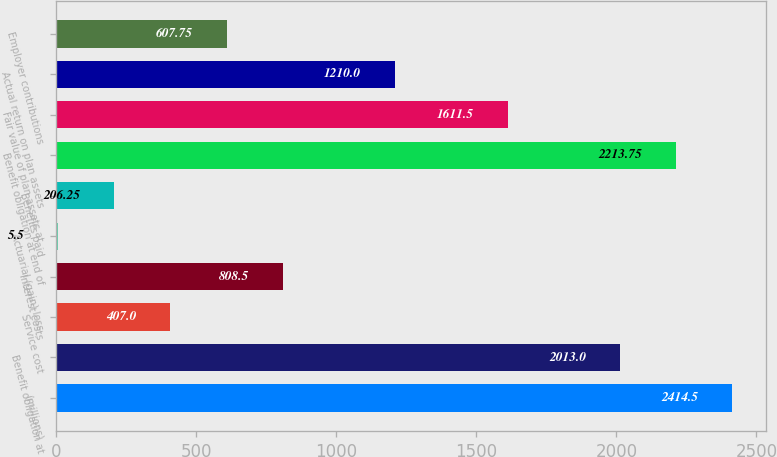Convert chart. <chart><loc_0><loc_0><loc_500><loc_500><bar_chart><fcel>(millions)<fcel>Benefit obligation at<fcel>Service cost<fcel>Interest costs<fcel>Actuarial (gain) loss<fcel>Benefits paid<fcel>Benefit obligation at end of<fcel>Fair value of plan assets at<fcel>Actual return on plan assets<fcel>Employer contributions<nl><fcel>2414.5<fcel>2013<fcel>407<fcel>808.5<fcel>5.5<fcel>206.25<fcel>2213.75<fcel>1611.5<fcel>1210<fcel>607.75<nl></chart> 